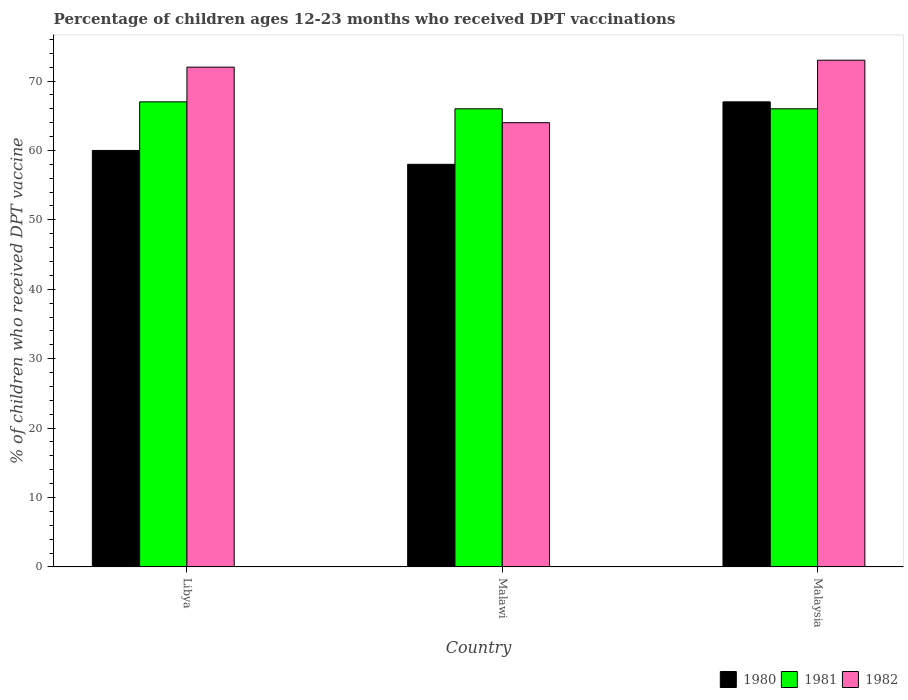What is the label of the 3rd group of bars from the left?
Provide a succinct answer. Malaysia. Across all countries, what is the maximum percentage of children who received DPT vaccination in 1980?
Provide a succinct answer. 67. Across all countries, what is the minimum percentage of children who received DPT vaccination in 1981?
Ensure brevity in your answer.  66. In which country was the percentage of children who received DPT vaccination in 1980 maximum?
Your answer should be compact. Malaysia. In which country was the percentage of children who received DPT vaccination in 1982 minimum?
Keep it short and to the point. Malawi. What is the total percentage of children who received DPT vaccination in 1980 in the graph?
Offer a very short reply. 185. What is the difference between the percentage of children who received DPT vaccination in 1982 in Libya and that in Malawi?
Give a very brief answer. 8. What is the difference between the percentage of children who received DPT vaccination in 1982 in Malaysia and the percentage of children who received DPT vaccination in 1980 in Libya?
Your response must be concise. 13. What is the average percentage of children who received DPT vaccination in 1980 per country?
Your answer should be compact. 61.67. What is the difference between the percentage of children who received DPT vaccination of/in 1982 and percentage of children who received DPT vaccination of/in 1981 in Malaysia?
Your answer should be compact. 7. In how many countries, is the percentage of children who received DPT vaccination in 1981 greater than 20 %?
Provide a short and direct response. 3. What is the ratio of the percentage of children who received DPT vaccination in 1980 in Libya to that in Malawi?
Ensure brevity in your answer.  1.03. Is the difference between the percentage of children who received DPT vaccination in 1982 in Libya and Malaysia greater than the difference between the percentage of children who received DPT vaccination in 1981 in Libya and Malaysia?
Make the answer very short. No. What is the difference between the highest and the lowest percentage of children who received DPT vaccination in 1980?
Ensure brevity in your answer.  9. In how many countries, is the percentage of children who received DPT vaccination in 1981 greater than the average percentage of children who received DPT vaccination in 1981 taken over all countries?
Provide a short and direct response. 1. Is the sum of the percentage of children who received DPT vaccination in 1980 in Libya and Malawi greater than the maximum percentage of children who received DPT vaccination in 1981 across all countries?
Your answer should be compact. Yes. What does the 1st bar from the right in Malaysia represents?
Keep it short and to the point. 1982. Is it the case that in every country, the sum of the percentage of children who received DPT vaccination in 1980 and percentage of children who received DPT vaccination in 1982 is greater than the percentage of children who received DPT vaccination in 1981?
Give a very brief answer. Yes. How many bars are there?
Your response must be concise. 9. How many countries are there in the graph?
Your response must be concise. 3. What is the difference between two consecutive major ticks on the Y-axis?
Give a very brief answer. 10. Are the values on the major ticks of Y-axis written in scientific E-notation?
Keep it short and to the point. No. Does the graph contain any zero values?
Your answer should be very brief. No. How are the legend labels stacked?
Give a very brief answer. Horizontal. What is the title of the graph?
Offer a terse response. Percentage of children ages 12-23 months who received DPT vaccinations. What is the label or title of the X-axis?
Make the answer very short. Country. What is the label or title of the Y-axis?
Make the answer very short. % of children who received DPT vaccine. What is the % of children who received DPT vaccine in 1980 in Malawi?
Give a very brief answer. 58. What is the % of children who received DPT vaccine in 1981 in Malawi?
Ensure brevity in your answer.  66. What is the % of children who received DPT vaccine in 1980 in Malaysia?
Your answer should be compact. 67. What is the % of children who received DPT vaccine of 1982 in Malaysia?
Your response must be concise. 73. Across all countries, what is the maximum % of children who received DPT vaccine in 1980?
Make the answer very short. 67. Across all countries, what is the maximum % of children who received DPT vaccine in 1982?
Make the answer very short. 73. Across all countries, what is the minimum % of children who received DPT vaccine in 1980?
Ensure brevity in your answer.  58. Across all countries, what is the minimum % of children who received DPT vaccine in 1981?
Ensure brevity in your answer.  66. What is the total % of children who received DPT vaccine of 1980 in the graph?
Provide a short and direct response. 185. What is the total % of children who received DPT vaccine in 1981 in the graph?
Your response must be concise. 199. What is the total % of children who received DPT vaccine in 1982 in the graph?
Offer a very short reply. 209. What is the difference between the % of children who received DPT vaccine of 1980 in Libya and that in Malawi?
Make the answer very short. 2. What is the difference between the % of children who received DPT vaccine in 1982 in Libya and that in Malawi?
Provide a succinct answer. 8. What is the difference between the % of children who received DPT vaccine in 1981 in Libya and that in Malaysia?
Provide a short and direct response. 1. What is the difference between the % of children who received DPT vaccine of 1980 in Malawi and that in Malaysia?
Give a very brief answer. -9. What is the difference between the % of children who received DPT vaccine of 1980 in Libya and the % of children who received DPT vaccine of 1981 in Malawi?
Offer a very short reply. -6. What is the difference between the % of children who received DPT vaccine in 1980 in Libya and the % of children who received DPT vaccine in 1982 in Malawi?
Offer a terse response. -4. What is the difference between the % of children who received DPT vaccine of 1980 in Libya and the % of children who received DPT vaccine of 1981 in Malaysia?
Offer a terse response. -6. What is the difference between the % of children who received DPT vaccine of 1980 in Malawi and the % of children who received DPT vaccine of 1982 in Malaysia?
Offer a very short reply. -15. What is the difference between the % of children who received DPT vaccine of 1981 in Malawi and the % of children who received DPT vaccine of 1982 in Malaysia?
Offer a very short reply. -7. What is the average % of children who received DPT vaccine of 1980 per country?
Give a very brief answer. 61.67. What is the average % of children who received DPT vaccine of 1981 per country?
Your answer should be compact. 66.33. What is the average % of children who received DPT vaccine of 1982 per country?
Ensure brevity in your answer.  69.67. What is the difference between the % of children who received DPT vaccine of 1980 and % of children who received DPT vaccine of 1981 in Libya?
Your answer should be very brief. -7. What is the difference between the % of children who received DPT vaccine in 1980 and % of children who received DPT vaccine in 1982 in Libya?
Ensure brevity in your answer.  -12. What is the difference between the % of children who received DPT vaccine of 1981 and % of children who received DPT vaccine of 1982 in Libya?
Make the answer very short. -5. What is the difference between the % of children who received DPT vaccine of 1980 and % of children who received DPT vaccine of 1981 in Malawi?
Offer a terse response. -8. What is the difference between the % of children who received DPT vaccine of 1980 and % of children who received DPT vaccine of 1982 in Malawi?
Provide a succinct answer. -6. What is the difference between the % of children who received DPT vaccine in 1980 and % of children who received DPT vaccine in 1982 in Malaysia?
Provide a short and direct response. -6. What is the ratio of the % of children who received DPT vaccine of 1980 in Libya to that in Malawi?
Provide a succinct answer. 1.03. What is the ratio of the % of children who received DPT vaccine in 1981 in Libya to that in Malawi?
Provide a short and direct response. 1.02. What is the ratio of the % of children who received DPT vaccine of 1980 in Libya to that in Malaysia?
Give a very brief answer. 0.9. What is the ratio of the % of children who received DPT vaccine in 1981 in Libya to that in Malaysia?
Your answer should be compact. 1.02. What is the ratio of the % of children who received DPT vaccine of 1982 in Libya to that in Malaysia?
Your response must be concise. 0.99. What is the ratio of the % of children who received DPT vaccine in 1980 in Malawi to that in Malaysia?
Your response must be concise. 0.87. What is the ratio of the % of children who received DPT vaccine in 1982 in Malawi to that in Malaysia?
Your answer should be compact. 0.88. What is the difference between the highest and the second highest % of children who received DPT vaccine of 1981?
Provide a short and direct response. 1. What is the difference between the highest and the lowest % of children who received DPT vaccine of 1980?
Your answer should be compact. 9. What is the difference between the highest and the lowest % of children who received DPT vaccine in 1982?
Keep it short and to the point. 9. 